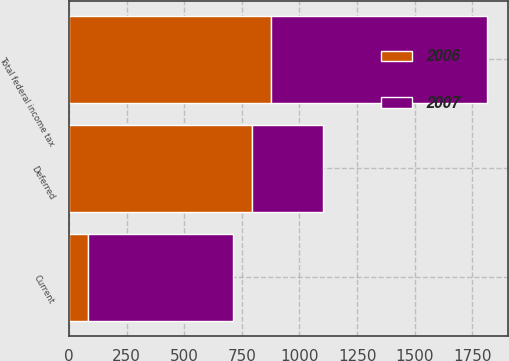<chart> <loc_0><loc_0><loc_500><loc_500><stacked_bar_chart><ecel><fcel>Current<fcel>Deferred<fcel>Total federal income tax<nl><fcel>2007<fcel>630<fcel>308<fcel>938<nl><fcel>2006<fcel>81<fcel>796<fcel>877<nl></chart> 